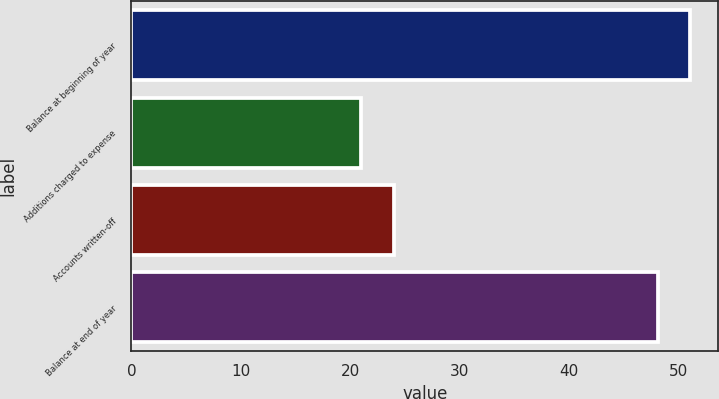Convert chart to OTSL. <chart><loc_0><loc_0><loc_500><loc_500><bar_chart><fcel>Balance at beginning of year<fcel>Additions charged to expense<fcel>Accounts written-off<fcel>Balance at end of year<nl><fcel>51.09<fcel>21<fcel>23.99<fcel>48.1<nl></chart> 